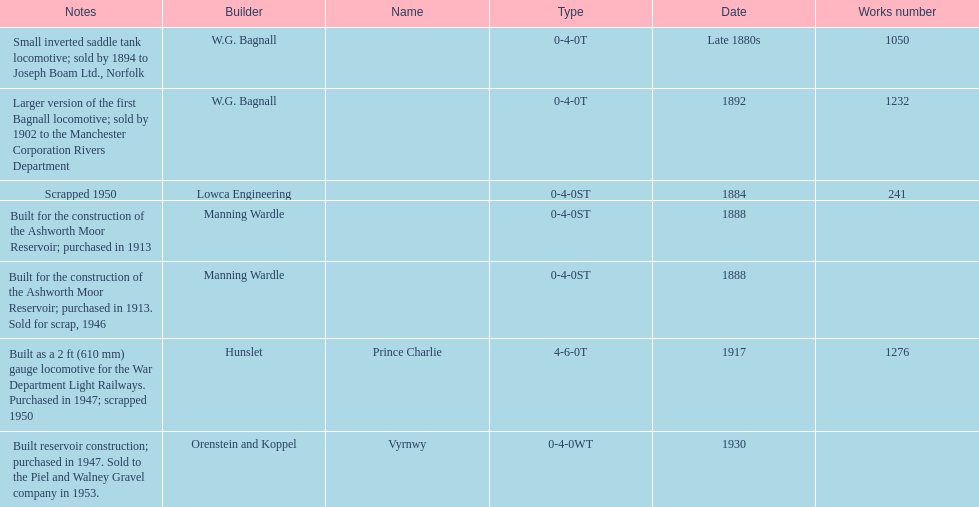Which locomotive builder built a locomotive after 1888 and built the locomotive as a 2ft gauge locomotive? Hunslet. 